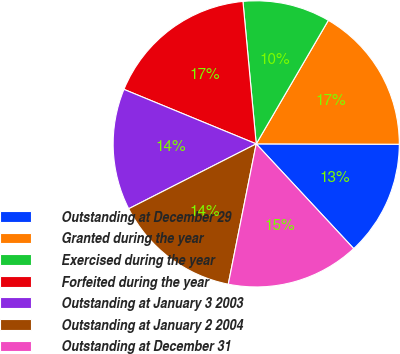<chart> <loc_0><loc_0><loc_500><loc_500><pie_chart><fcel>Outstanding at December 29<fcel>Granted during the year<fcel>Exercised during the year<fcel>Forfeited during the year<fcel>Outstanding at January 3 2003<fcel>Outstanding at January 2 2004<fcel>Outstanding at December 31<nl><fcel>13.03%<fcel>16.63%<fcel>9.89%<fcel>17.3%<fcel>13.71%<fcel>14.38%<fcel>15.06%<nl></chart> 